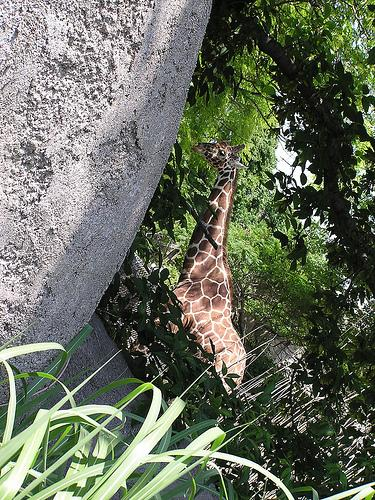Count the giraffes in the image. There is one giraffe in the photo. What type of plant is growing next to the large gray rock? Green weeds are growing next to the rock. Examine the details on the giraffe's head. The giraffe has white ears, small horns, and a brown mane down its neck. Provide a short overview of the picture's main subject and setting. A brown and white giraffe grazing under a tree with a large grey rock and tall green grass in the foreground. Identify the main animal in the image and what it is doing. The main animal is a giraffe and it's grazing on tree leaves. Describe the interaction between the giraffe and its environment. The giraffe is grazing from a tree, standing next to a rock and surrounded by tall green grass and green plants. Analyze the textures on the rock in the image. The rock has rounded indents and a chipped, coarse surface. What is the main object in the image and what action is it performing? A giraffe is the main object, and it is grazing from a tree. What is the primary color of the rock next to the giraffe? The primary color of the rock is gray. Explain how sunlight is portrayed in the image. Sunlight is reflected on green blades of grass and on the giraffe's back. Identify areas of green leaves in the image. X:209 Y:6 Width:162 Height:162; X:3 Y:339 Width:280 Height:280; X:5 Y:381 Width:228 Height:228; X:96 Y:257 Width:249 Height:249; X:160 Y:2 Width:213 Height:213; X:96 Y:0 Width:278 Height:278 Is there any text present in the image? No, there is no text present in the image. Are there any anomalies or oddities in the image? No evident anomalies or oddities Identify the object referred to as "rounded indents in the rock". X:86 Y:118 Width:58 Height:58 Identify the various expressions describing the giraffe in the picture. side of standing giraffe, head and neck of giraffe, mane on giraffe neck, giraffe grazing from tree, long neck of giraffe, brown mane down giraffes neck, small horn of giraffe, neck of the giraffe, body of the giraffe, brown spots on the giraffe, head of the giraffe, ear of the giraffe, one giraffe in the photo, brown and white giraffe, sunlight on a giraffes back, giraffe in the wild, giraffe ears, giraffe looking for food, spot on a giraffe Choose the correct description of the scene: a) A giraffe in a city park b) A giraffe in the wild c) A giraffe in a zoo b) A giraffe in the wild Create a caption for this image. A brown and white giraffe grazes from a tree, surrounded by green plants and a large gray rock in the sunlight. Describe the interaction between the giraffe and its surroundings. The giraffe is grazing from a tree while standing near a large gray rock and green plants in the sunlight. What are some of the noticeable attributes of the giraffe? Brown spots, long neck, small horn, white ear, and a brown mane Determine the quality level of this image. High quality with clear details and vibrant colors What emotion does the image evoke? Peaceful and serene 